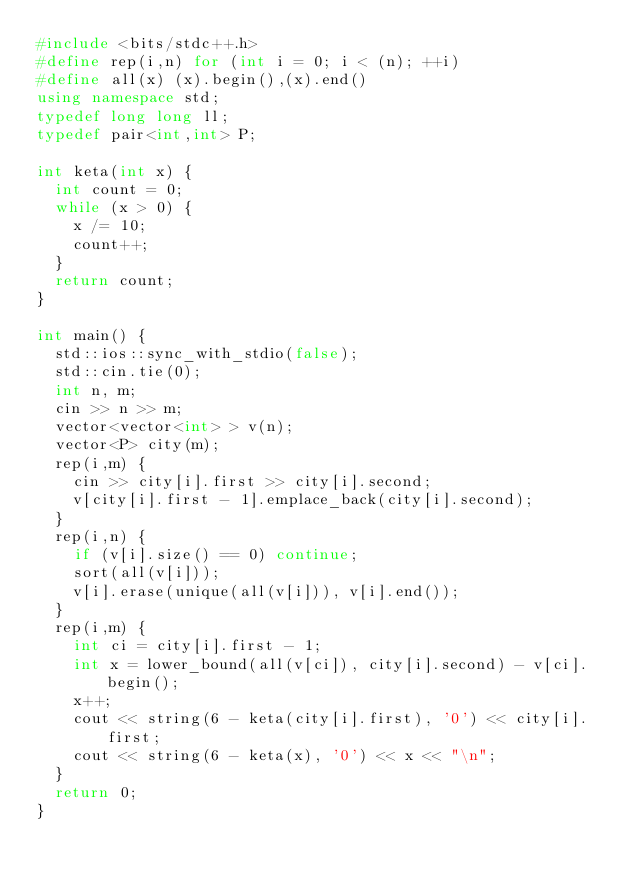<code> <loc_0><loc_0><loc_500><loc_500><_C++_>#include <bits/stdc++.h>
#define rep(i,n) for (int i = 0; i < (n); ++i)
#define all(x) (x).begin(),(x).end()
using namespace std;
typedef long long ll;
typedef pair<int,int> P;

int keta(int x) {
  int count = 0;
  while (x > 0) {
    x /= 10;
    count++;
  }
  return count;
}

int main() {
  std::ios::sync_with_stdio(false);
  std::cin.tie(0);
  int n, m;
  cin >> n >> m;
  vector<vector<int> > v(n);
  vector<P> city(m);
  rep(i,m) {
    cin >> city[i].first >> city[i].second;
    v[city[i].first - 1].emplace_back(city[i].second);
  }
  rep(i,n) {
    if (v[i].size() == 0) continue;
    sort(all(v[i]));
    v[i].erase(unique(all(v[i])), v[i].end());
  }
  rep(i,m) {
    int ci = city[i].first - 1;
    int x = lower_bound(all(v[ci]), city[i].second) - v[ci].begin();
    x++;
    cout << string(6 - keta(city[i].first), '0') << city[i].first;
    cout << string(6 - keta(x), '0') << x << "\n";
  }
  return 0;
}</code> 